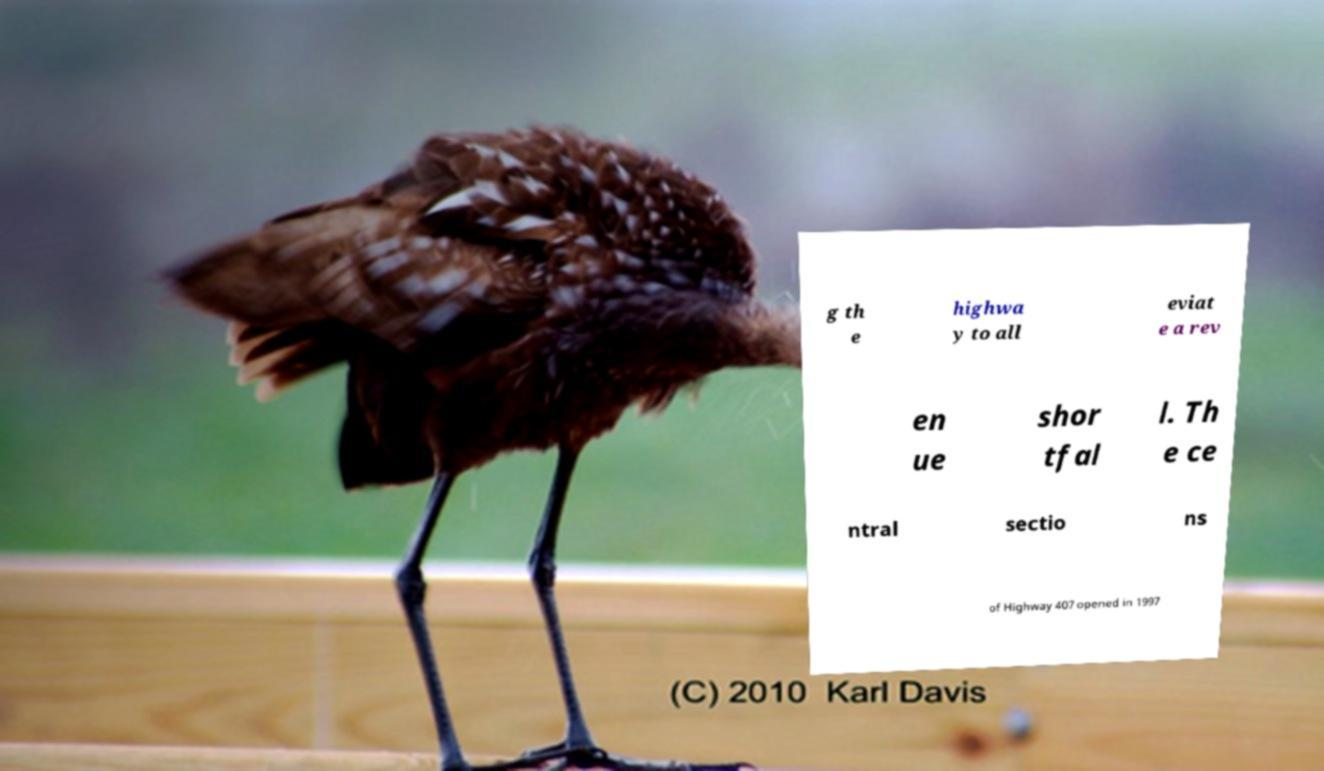Could you assist in decoding the text presented in this image and type it out clearly? g th e highwa y to all eviat e a rev en ue shor tfal l. Th e ce ntral sectio ns of Highway 407 opened in 1997 